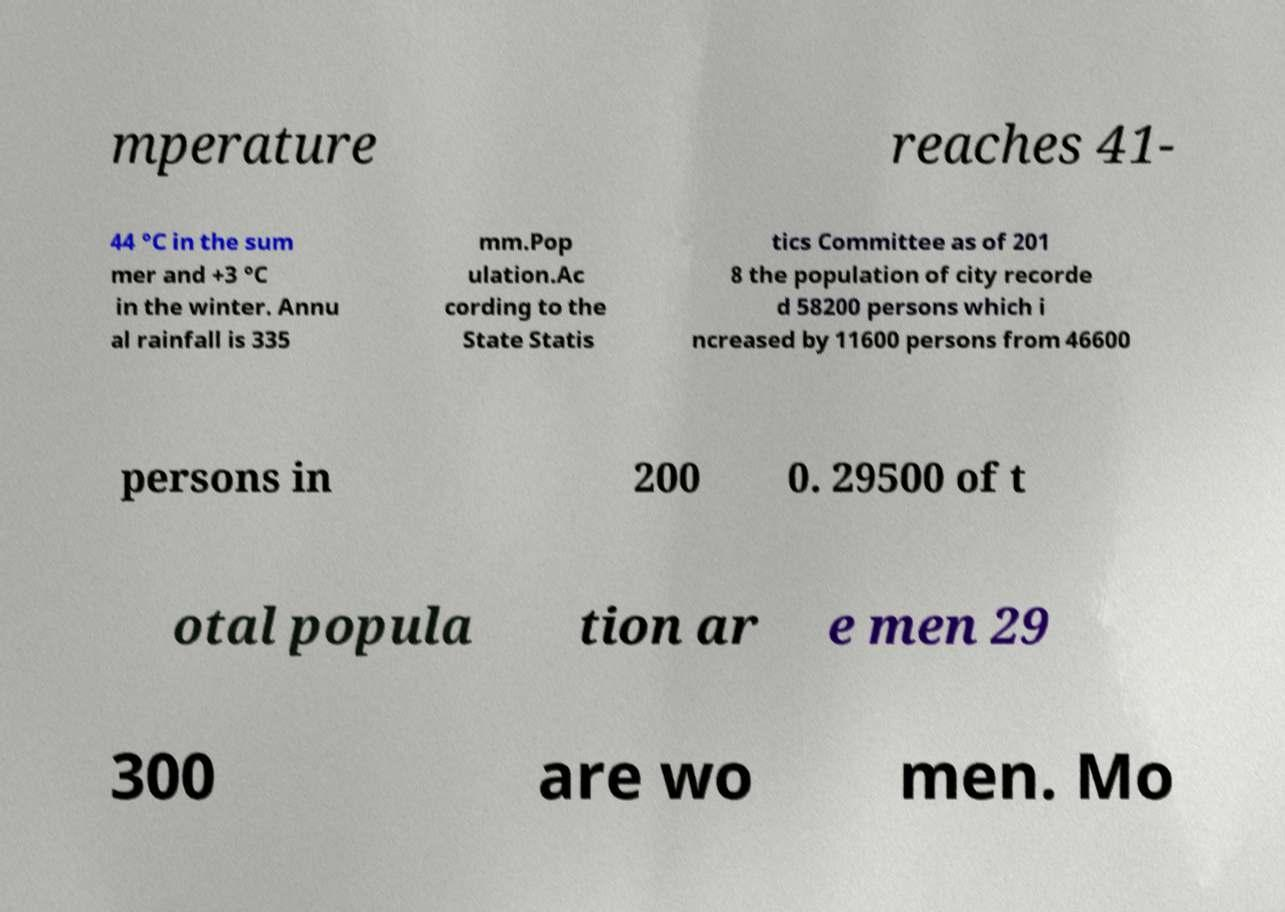Could you extract and type out the text from this image? mperature reaches 41- 44 °C in the sum mer and +3 °C in the winter. Annu al rainfall is 335 mm.Pop ulation.Ac cording to the State Statis tics Committee as of 201 8 the population of city recorde d 58200 persons which i ncreased by 11600 persons from 46600 persons in 200 0. 29500 of t otal popula tion ar e men 29 300 are wo men. Mo 